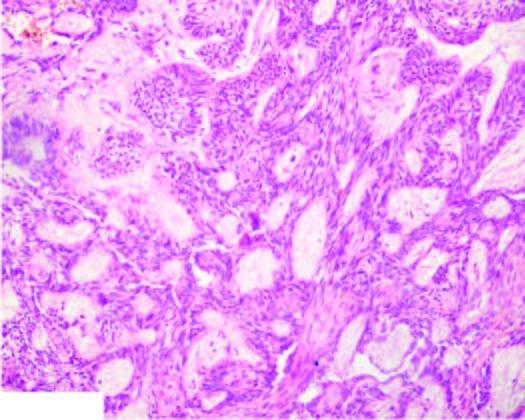do plexiform areas show irregular plexiform masses and network of strands of epithelial cells?
Answer the question using a single word or phrase. Yes 